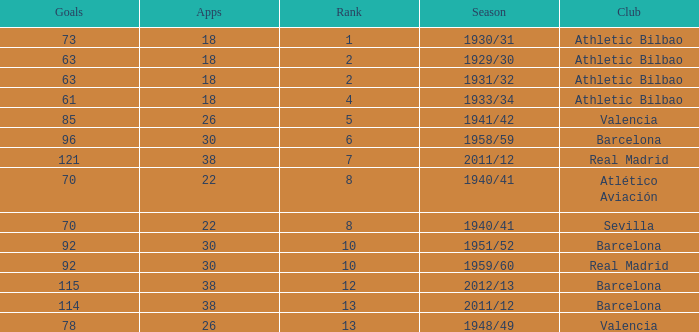What are the apps for less than 61 goals and before rank 6? None. 